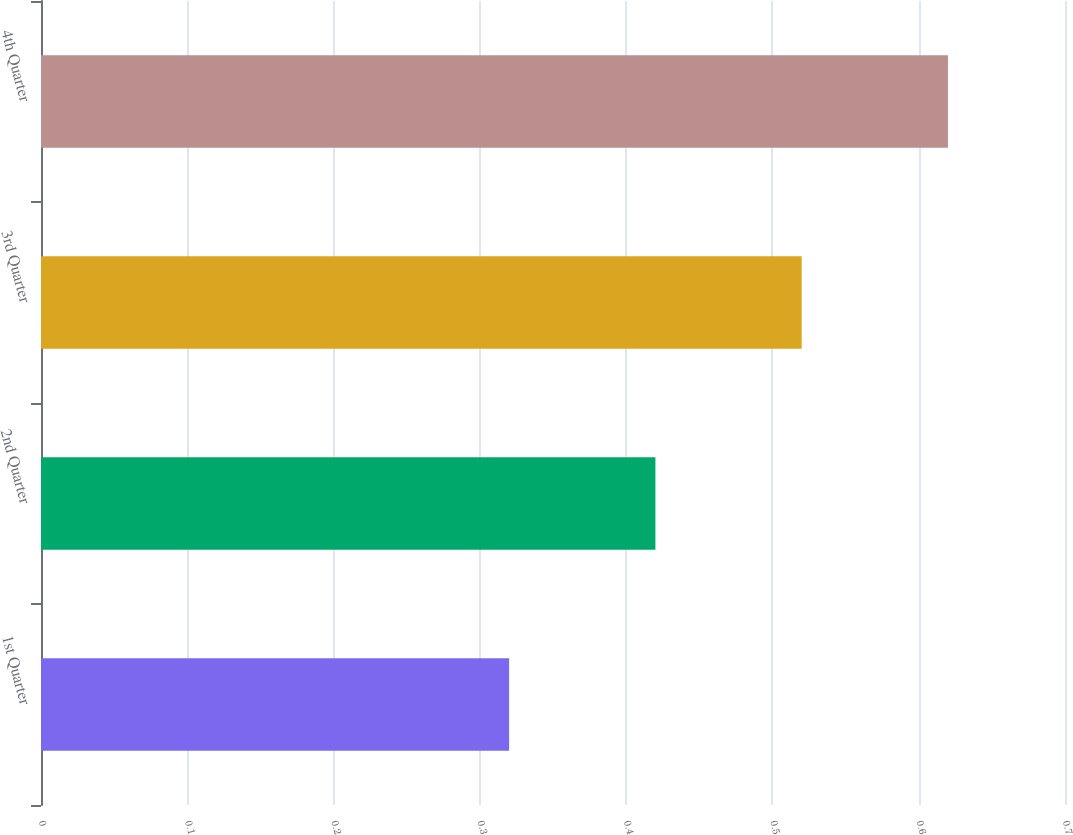<chart> <loc_0><loc_0><loc_500><loc_500><bar_chart><fcel>1st Quarter<fcel>2nd Quarter<fcel>3rd Quarter<fcel>4th Quarter<nl><fcel>0.32<fcel>0.42<fcel>0.52<fcel>0.62<nl></chart> 